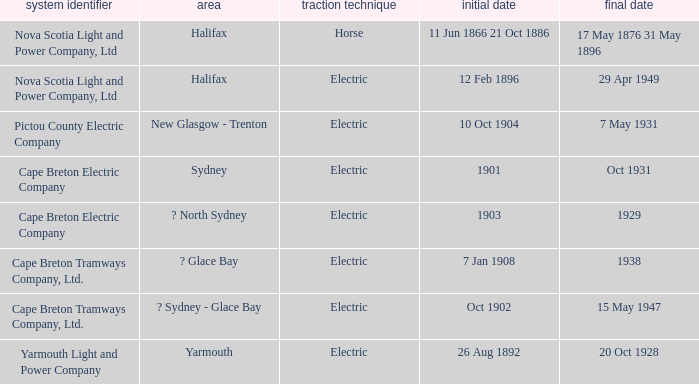What is the date (to) associated wiht a traction type of electric and the Yarmouth Light and Power Company system? 20 Oct 1928. 